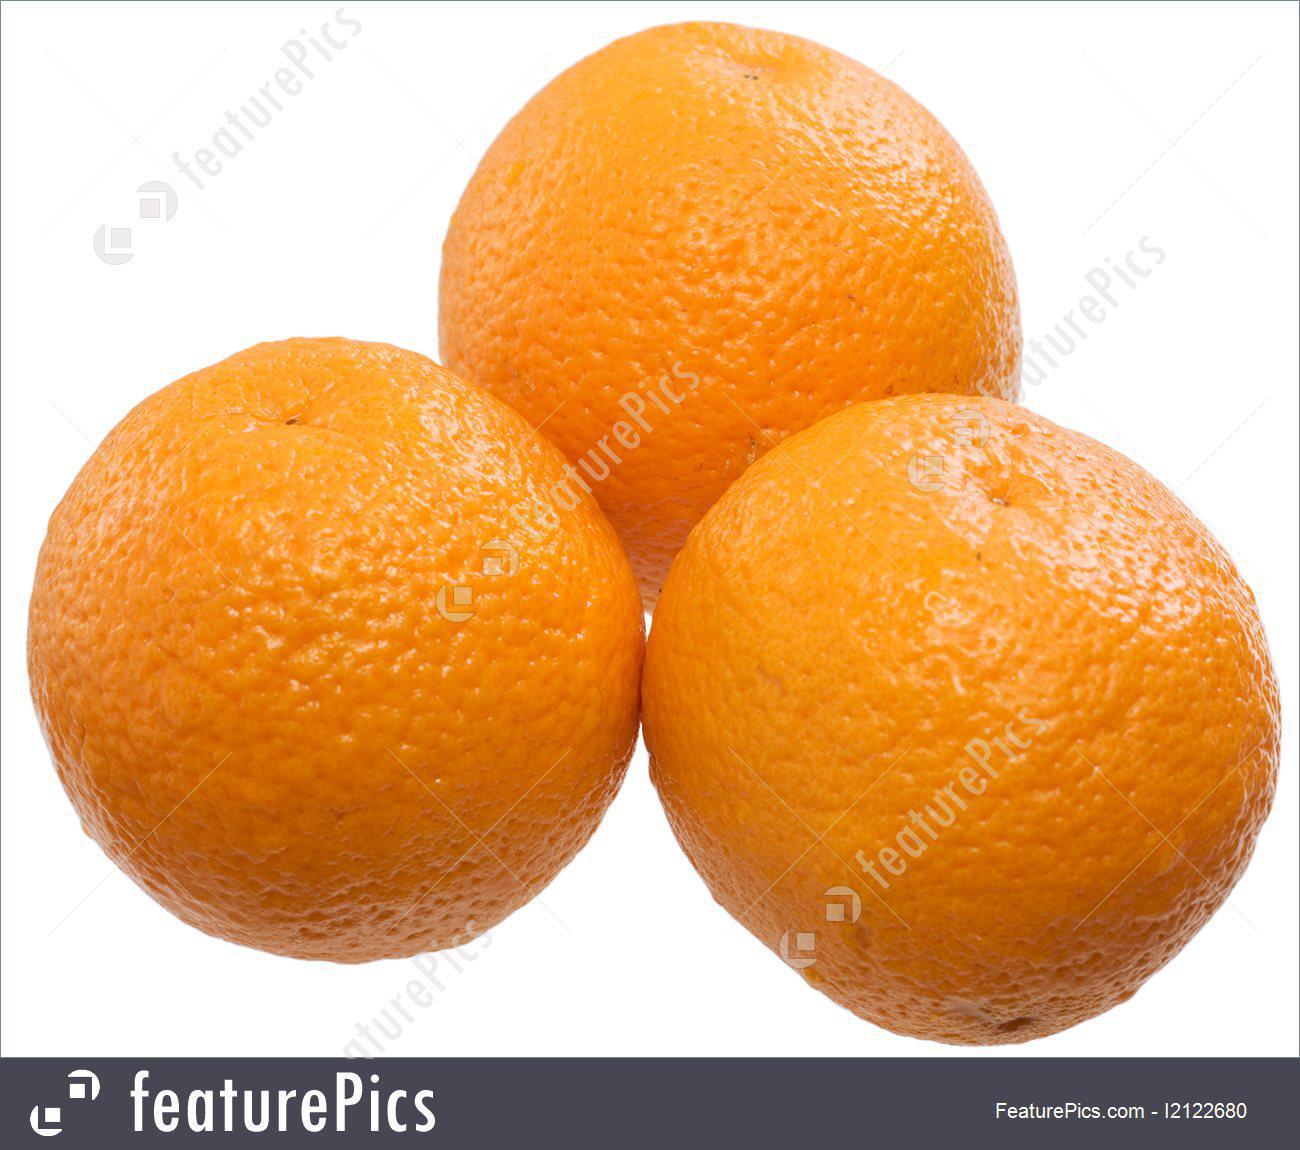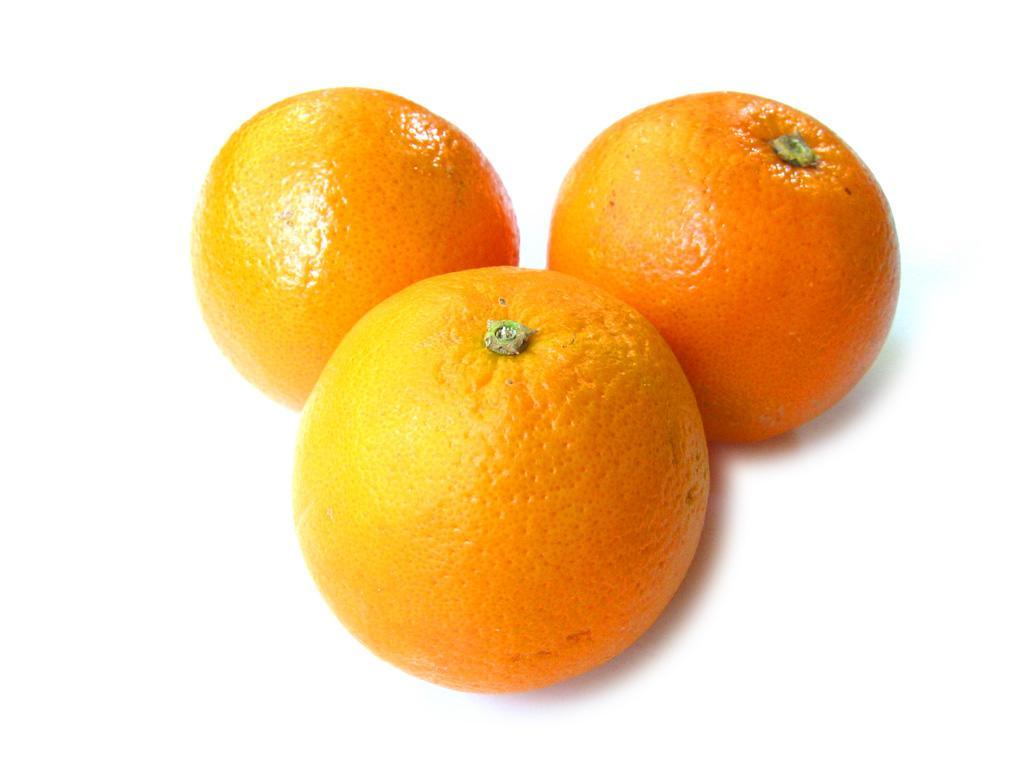The first image is the image on the left, the second image is the image on the right. Examine the images to the left and right. Is the description "There are at most 6 oranges total" accurate? Answer yes or no. Yes. The first image is the image on the left, the second image is the image on the right. Evaluate the accuracy of this statement regarding the images: "There are six oranges.". Is it true? Answer yes or no. Yes. 